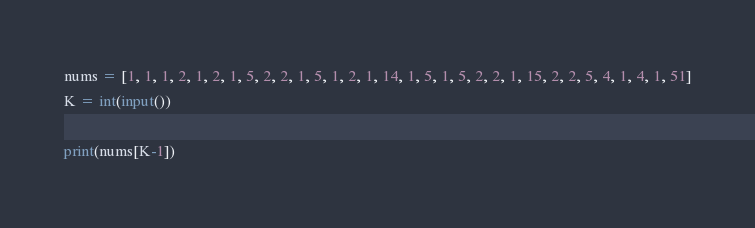Convert code to text. <code><loc_0><loc_0><loc_500><loc_500><_Python_>nums = [1, 1, 1, 2, 1, 2, 1, 5, 2, 2, 1, 5, 1, 2, 1, 14, 1, 5, 1, 5, 2, 2, 1, 15, 2, 2, 5, 4, 1, 4, 1, 51]
K = int(input())

print(nums[K-1])</code> 